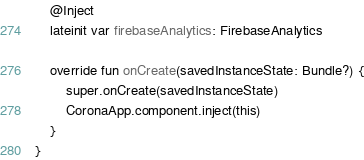<code> <loc_0><loc_0><loc_500><loc_500><_Kotlin_>
    @Inject
    lateinit var firebaseAnalytics: FirebaseAnalytics

    override fun onCreate(savedInstanceState: Bundle?) {
        super.onCreate(savedInstanceState)
        CoronaApp.component.inject(this)
    }
}</code> 